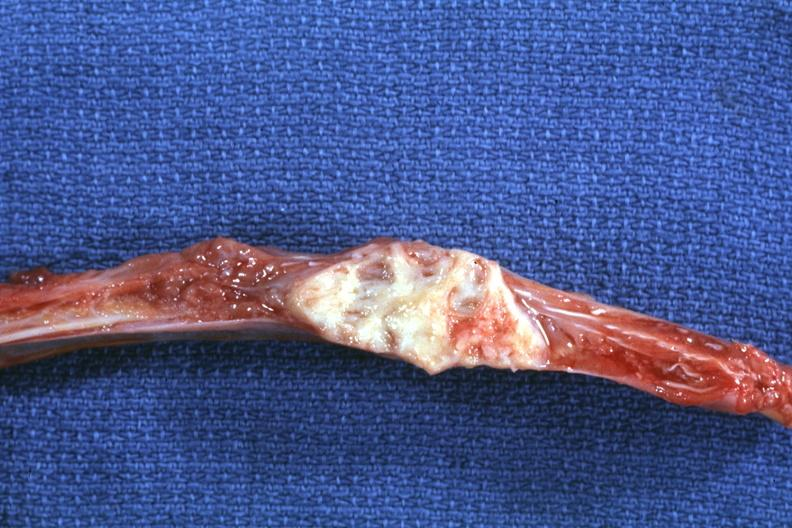what is present?
Answer the question using a single word or phrase. Joints 